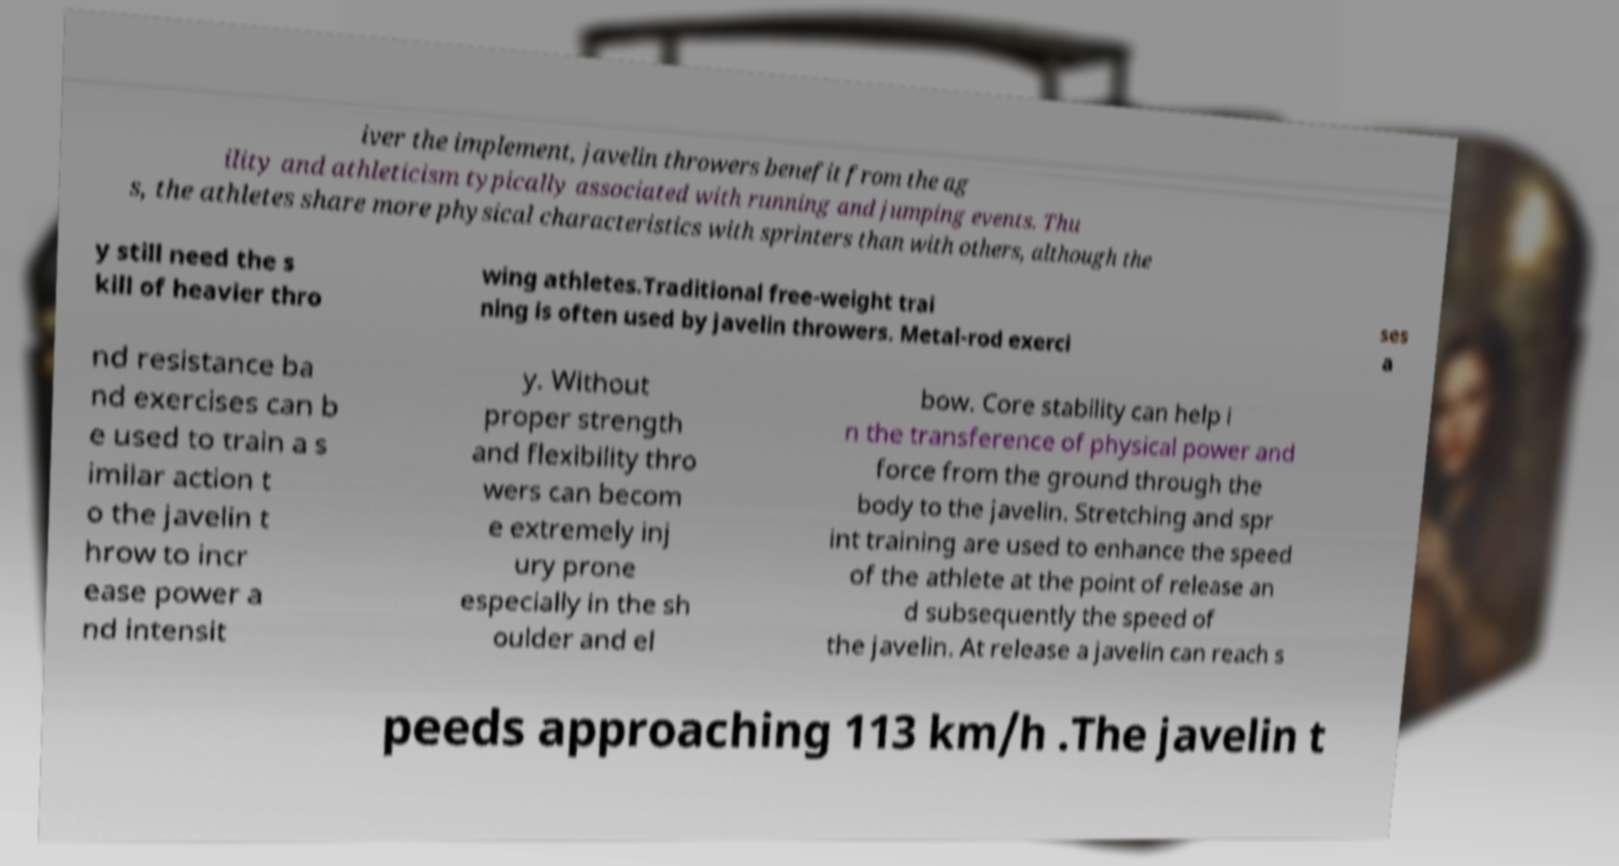What messages or text are displayed in this image? I need them in a readable, typed format. iver the implement, javelin throwers benefit from the ag ility and athleticism typically associated with running and jumping events. Thu s, the athletes share more physical characteristics with sprinters than with others, although the y still need the s kill of heavier thro wing athletes.Traditional free-weight trai ning is often used by javelin throwers. Metal-rod exerci ses a nd resistance ba nd exercises can b e used to train a s imilar action t o the javelin t hrow to incr ease power a nd intensit y. Without proper strength and flexibility thro wers can becom e extremely inj ury prone especially in the sh oulder and el bow. Core stability can help i n the transference of physical power and force from the ground through the body to the javelin. Stretching and spr int training are used to enhance the speed of the athlete at the point of release an d subsequently the speed of the javelin. At release a javelin can reach s peeds approaching 113 km/h .The javelin t 